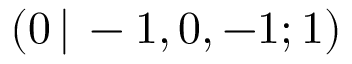Convert formula to latex. <formula><loc_0><loc_0><loc_500><loc_500>( 0 \, | \, - 1 , 0 , - 1 ; 1 )</formula> 